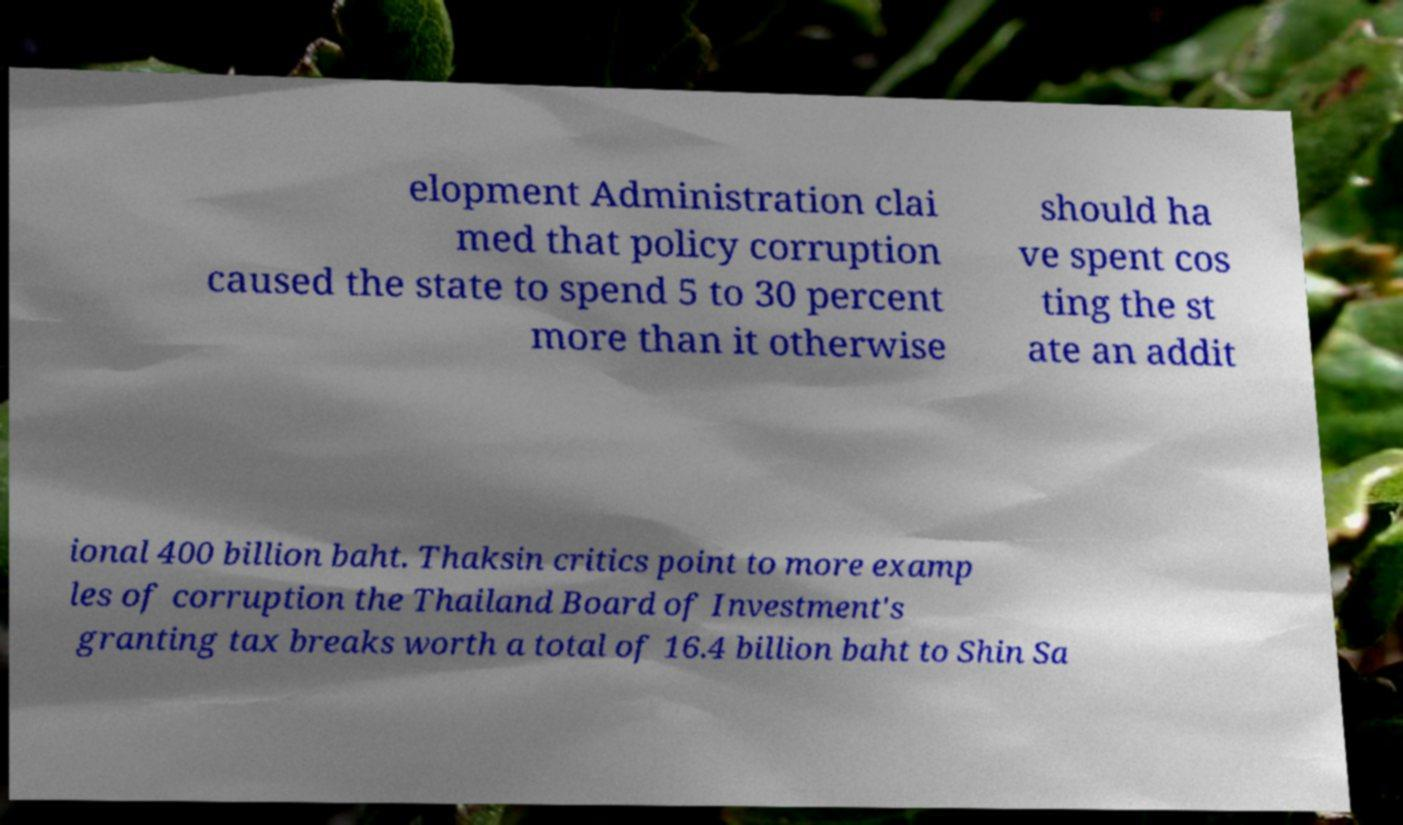I need the written content from this picture converted into text. Can you do that? elopment Administration clai med that policy corruption caused the state to spend 5 to 30 percent more than it otherwise should ha ve spent cos ting the st ate an addit ional 400 billion baht. Thaksin critics point to more examp les of corruption the Thailand Board of Investment's granting tax breaks worth a total of 16.4 billion baht to Shin Sa 